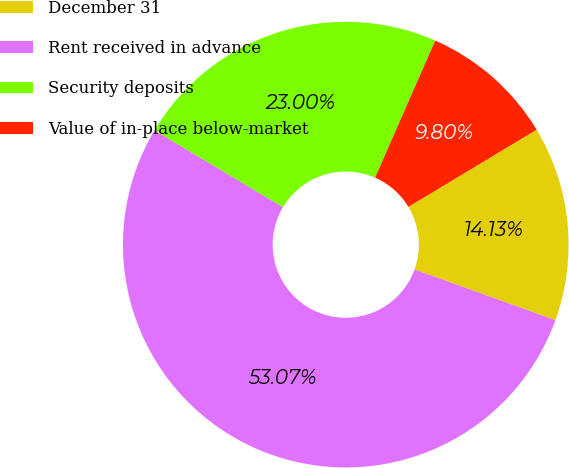Convert chart to OTSL. <chart><loc_0><loc_0><loc_500><loc_500><pie_chart><fcel>December 31<fcel>Rent received in advance<fcel>Security deposits<fcel>Value of in-place below-market<nl><fcel>14.13%<fcel>53.07%<fcel>23.0%<fcel>9.8%<nl></chart> 